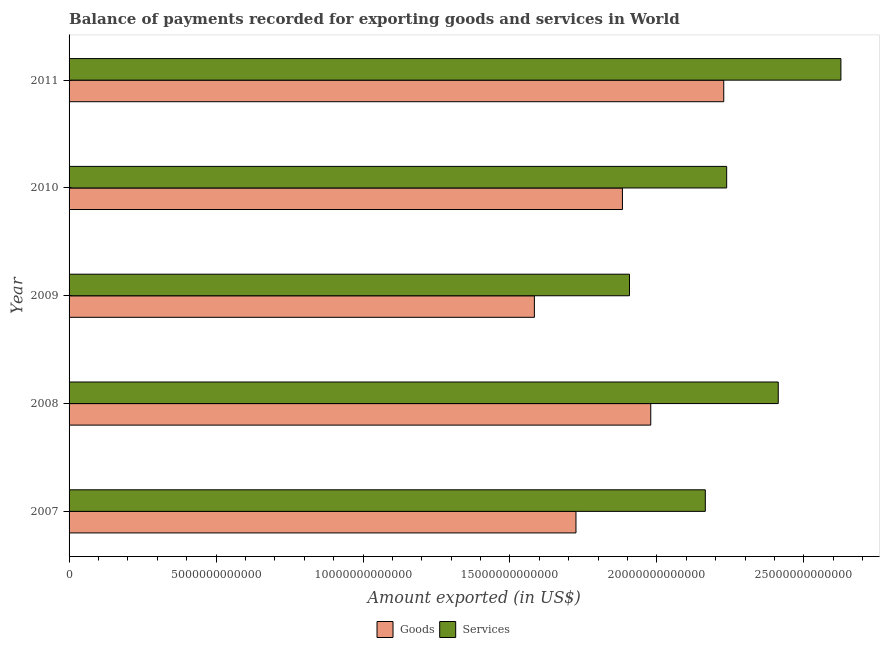Are the number of bars per tick equal to the number of legend labels?
Ensure brevity in your answer.  Yes. Are the number of bars on each tick of the Y-axis equal?
Provide a succinct answer. Yes. How many bars are there on the 5th tick from the top?
Provide a succinct answer. 2. How many bars are there on the 3rd tick from the bottom?
Offer a terse response. 2. What is the amount of goods exported in 2007?
Provide a succinct answer. 1.72e+13. Across all years, what is the maximum amount of services exported?
Ensure brevity in your answer.  2.63e+13. Across all years, what is the minimum amount of services exported?
Give a very brief answer. 1.91e+13. In which year was the amount of services exported minimum?
Offer a terse response. 2009. What is the total amount of services exported in the graph?
Provide a succinct answer. 1.13e+14. What is the difference between the amount of services exported in 2007 and that in 2011?
Give a very brief answer. -4.61e+12. What is the difference between the amount of services exported in 2009 and the amount of goods exported in 2007?
Your answer should be very brief. 1.82e+12. What is the average amount of goods exported per year?
Provide a short and direct response. 1.88e+13. In the year 2008, what is the difference between the amount of goods exported and amount of services exported?
Offer a terse response. -4.34e+12. In how many years, is the amount of goods exported greater than 4000000000000 US$?
Provide a short and direct response. 5. What is the ratio of the amount of services exported in 2008 to that in 2009?
Keep it short and to the point. 1.26. What is the difference between the highest and the second highest amount of services exported?
Your answer should be very brief. 2.13e+12. What is the difference between the highest and the lowest amount of goods exported?
Make the answer very short. 6.44e+12. Is the sum of the amount of services exported in 2008 and 2011 greater than the maximum amount of goods exported across all years?
Offer a very short reply. Yes. What does the 2nd bar from the top in 2009 represents?
Your answer should be compact. Goods. What does the 1st bar from the bottom in 2009 represents?
Provide a short and direct response. Goods. How many years are there in the graph?
Keep it short and to the point. 5. What is the difference between two consecutive major ticks on the X-axis?
Your answer should be compact. 5.00e+12. Are the values on the major ticks of X-axis written in scientific E-notation?
Your response must be concise. No. How many legend labels are there?
Give a very brief answer. 2. What is the title of the graph?
Your response must be concise. Balance of payments recorded for exporting goods and services in World. What is the label or title of the X-axis?
Provide a short and direct response. Amount exported (in US$). What is the label or title of the Y-axis?
Make the answer very short. Year. What is the Amount exported (in US$) in Goods in 2007?
Your answer should be compact. 1.72e+13. What is the Amount exported (in US$) of Services in 2007?
Provide a succinct answer. 2.16e+13. What is the Amount exported (in US$) in Goods in 2008?
Provide a short and direct response. 1.98e+13. What is the Amount exported (in US$) of Services in 2008?
Offer a very short reply. 2.41e+13. What is the Amount exported (in US$) in Goods in 2009?
Offer a terse response. 1.58e+13. What is the Amount exported (in US$) of Services in 2009?
Your response must be concise. 1.91e+13. What is the Amount exported (in US$) of Goods in 2010?
Offer a terse response. 1.88e+13. What is the Amount exported (in US$) in Services in 2010?
Offer a terse response. 2.24e+13. What is the Amount exported (in US$) of Goods in 2011?
Provide a succinct answer. 2.23e+13. What is the Amount exported (in US$) in Services in 2011?
Your answer should be compact. 2.63e+13. Across all years, what is the maximum Amount exported (in US$) in Goods?
Your response must be concise. 2.23e+13. Across all years, what is the maximum Amount exported (in US$) of Services?
Your answer should be very brief. 2.63e+13. Across all years, what is the minimum Amount exported (in US$) of Goods?
Your answer should be compact. 1.58e+13. Across all years, what is the minimum Amount exported (in US$) of Services?
Give a very brief answer. 1.91e+13. What is the total Amount exported (in US$) of Goods in the graph?
Offer a terse response. 9.40e+13. What is the total Amount exported (in US$) of Services in the graph?
Offer a very short reply. 1.13e+14. What is the difference between the Amount exported (in US$) in Goods in 2007 and that in 2008?
Keep it short and to the point. -2.54e+12. What is the difference between the Amount exported (in US$) in Services in 2007 and that in 2008?
Your answer should be very brief. -2.48e+12. What is the difference between the Amount exported (in US$) in Goods in 2007 and that in 2009?
Offer a very short reply. 1.41e+12. What is the difference between the Amount exported (in US$) of Services in 2007 and that in 2009?
Your answer should be compact. 2.58e+12. What is the difference between the Amount exported (in US$) in Goods in 2007 and that in 2010?
Give a very brief answer. -1.58e+12. What is the difference between the Amount exported (in US$) of Services in 2007 and that in 2010?
Give a very brief answer. -7.27e+11. What is the difference between the Amount exported (in US$) in Goods in 2007 and that in 2011?
Provide a short and direct response. -5.03e+12. What is the difference between the Amount exported (in US$) of Services in 2007 and that in 2011?
Keep it short and to the point. -4.61e+12. What is the difference between the Amount exported (in US$) in Goods in 2008 and that in 2009?
Offer a very short reply. 3.96e+12. What is the difference between the Amount exported (in US$) in Services in 2008 and that in 2009?
Your answer should be very brief. 5.06e+12. What is the difference between the Amount exported (in US$) in Goods in 2008 and that in 2010?
Your answer should be compact. 9.63e+11. What is the difference between the Amount exported (in US$) of Services in 2008 and that in 2010?
Offer a very short reply. 1.76e+12. What is the difference between the Amount exported (in US$) of Goods in 2008 and that in 2011?
Your answer should be compact. -2.48e+12. What is the difference between the Amount exported (in US$) in Services in 2008 and that in 2011?
Provide a succinct answer. -2.13e+12. What is the difference between the Amount exported (in US$) of Goods in 2009 and that in 2010?
Your answer should be compact. -3.00e+12. What is the difference between the Amount exported (in US$) in Services in 2009 and that in 2010?
Give a very brief answer. -3.31e+12. What is the difference between the Amount exported (in US$) in Goods in 2009 and that in 2011?
Offer a terse response. -6.44e+12. What is the difference between the Amount exported (in US$) of Services in 2009 and that in 2011?
Offer a very short reply. -7.19e+12. What is the difference between the Amount exported (in US$) in Goods in 2010 and that in 2011?
Provide a succinct answer. -3.45e+12. What is the difference between the Amount exported (in US$) in Services in 2010 and that in 2011?
Ensure brevity in your answer.  -3.89e+12. What is the difference between the Amount exported (in US$) in Goods in 2007 and the Amount exported (in US$) in Services in 2008?
Provide a succinct answer. -6.88e+12. What is the difference between the Amount exported (in US$) in Goods in 2007 and the Amount exported (in US$) in Services in 2009?
Provide a succinct answer. -1.82e+12. What is the difference between the Amount exported (in US$) in Goods in 2007 and the Amount exported (in US$) in Services in 2010?
Provide a short and direct response. -5.13e+12. What is the difference between the Amount exported (in US$) of Goods in 2007 and the Amount exported (in US$) of Services in 2011?
Provide a short and direct response. -9.01e+12. What is the difference between the Amount exported (in US$) in Goods in 2008 and the Amount exported (in US$) in Services in 2009?
Offer a very short reply. 7.23e+11. What is the difference between the Amount exported (in US$) of Goods in 2008 and the Amount exported (in US$) of Services in 2010?
Your answer should be very brief. -2.58e+12. What is the difference between the Amount exported (in US$) in Goods in 2008 and the Amount exported (in US$) in Services in 2011?
Make the answer very short. -6.47e+12. What is the difference between the Amount exported (in US$) of Goods in 2009 and the Amount exported (in US$) of Services in 2010?
Provide a succinct answer. -6.54e+12. What is the difference between the Amount exported (in US$) of Goods in 2009 and the Amount exported (in US$) of Services in 2011?
Offer a very short reply. -1.04e+13. What is the difference between the Amount exported (in US$) in Goods in 2010 and the Amount exported (in US$) in Services in 2011?
Give a very brief answer. -7.43e+12. What is the average Amount exported (in US$) in Goods per year?
Provide a short and direct response. 1.88e+13. What is the average Amount exported (in US$) of Services per year?
Your answer should be very brief. 2.27e+13. In the year 2007, what is the difference between the Amount exported (in US$) in Goods and Amount exported (in US$) in Services?
Offer a terse response. -4.40e+12. In the year 2008, what is the difference between the Amount exported (in US$) in Goods and Amount exported (in US$) in Services?
Ensure brevity in your answer.  -4.34e+12. In the year 2009, what is the difference between the Amount exported (in US$) in Goods and Amount exported (in US$) in Services?
Offer a terse response. -3.24e+12. In the year 2010, what is the difference between the Amount exported (in US$) in Goods and Amount exported (in US$) in Services?
Ensure brevity in your answer.  -3.55e+12. In the year 2011, what is the difference between the Amount exported (in US$) in Goods and Amount exported (in US$) in Services?
Make the answer very short. -3.99e+12. What is the ratio of the Amount exported (in US$) of Goods in 2007 to that in 2008?
Provide a succinct answer. 0.87. What is the ratio of the Amount exported (in US$) of Services in 2007 to that in 2008?
Give a very brief answer. 0.9. What is the ratio of the Amount exported (in US$) of Goods in 2007 to that in 2009?
Your answer should be compact. 1.09. What is the ratio of the Amount exported (in US$) of Services in 2007 to that in 2009?
Offer a very short reply. 1.14. What is the ratio of the Amount exported (in US$) of Goods in 2007 to that in 2010?
Give a very brief answer. 0.92. What is the ratio of the Amount exported (in US$) in Services in 2007 to that in 2010?
Your answer should be very brief. 0.97. What is the ratio of the Amount exported (in US$) in Goods in 2007 to that in 2011?
Ensure brevity in your answer.  0.77. What is the ratio of the Amount exported (in US$) of Services in 2007 to that in 2011?
Give a very brief answer. 0.82. What is the ratio of the Amount exported (in US$) in Goods in 2008 to that in 2009?
Make the answer very short. 1.25. What is the ratio of the Amount exported (in US$) in Services in 2008 to that in 2009?
Give a very brief answer. 1.27. What is the ratio of the Amount exported (in US$) of Goods in 2008 to that in 2010?
Your answer should be very brief. 1.05. What is the ratio of the Amount exported (in US$) in Services in 2008 to that in 2010?
Offer a terse response. 1.08. What is the ratio of the Amount exported (in US$) in Goods in 2008 to that in 2011?
Offer a terse response. 0.89. What is the ratio of the Amount exported (in US$) of Services in 2008 to that in 2011?
Make the answer very short. 0.92. What is the ratio of the Amount exported (in US$) in Goods in 2009 to that in 2010?
Keep it short and to the point. 0.84. What is the ratio of the Amount exported (in US$) in Services in 2009 to that in 2010?
Make the answer very short. 0.85. What is the ratio of the Amount exported (in US$) of Goods in 2009 to that in 2011?
Your answer should be compact. 0.71. What is the ratio of the Amount exported (in US$) in Services in 2009 to that in 2011?
Provide a short and direct response. 0.73. What is the ratio of the Amount exported (in US$) in Goods in 2010 to that in 2011?
Ensure brevity in your answer.  0.85. What is the ratio of the Amount exported (in US$) of Services in 2010 to that in 2011?
Give a very brief answer. 0.85. What is the difference between the highest and the second highest Amount exported (in US$) of Goods?
Offer a very short reply. 2.48e+12. What is the difference between the highest and the second highest Amount exported (in US$) of Services?
Your answer should be very brief. 2.13e+12. What is the difference between the highest and the lowest Amount exported (in US$) in Goods?
Provide a short and direct response. 6.44e+12. What is the difference between the highest and the lowest Amount exported (in US$) of Services?
Your response must be concise. 7.19e+12. 